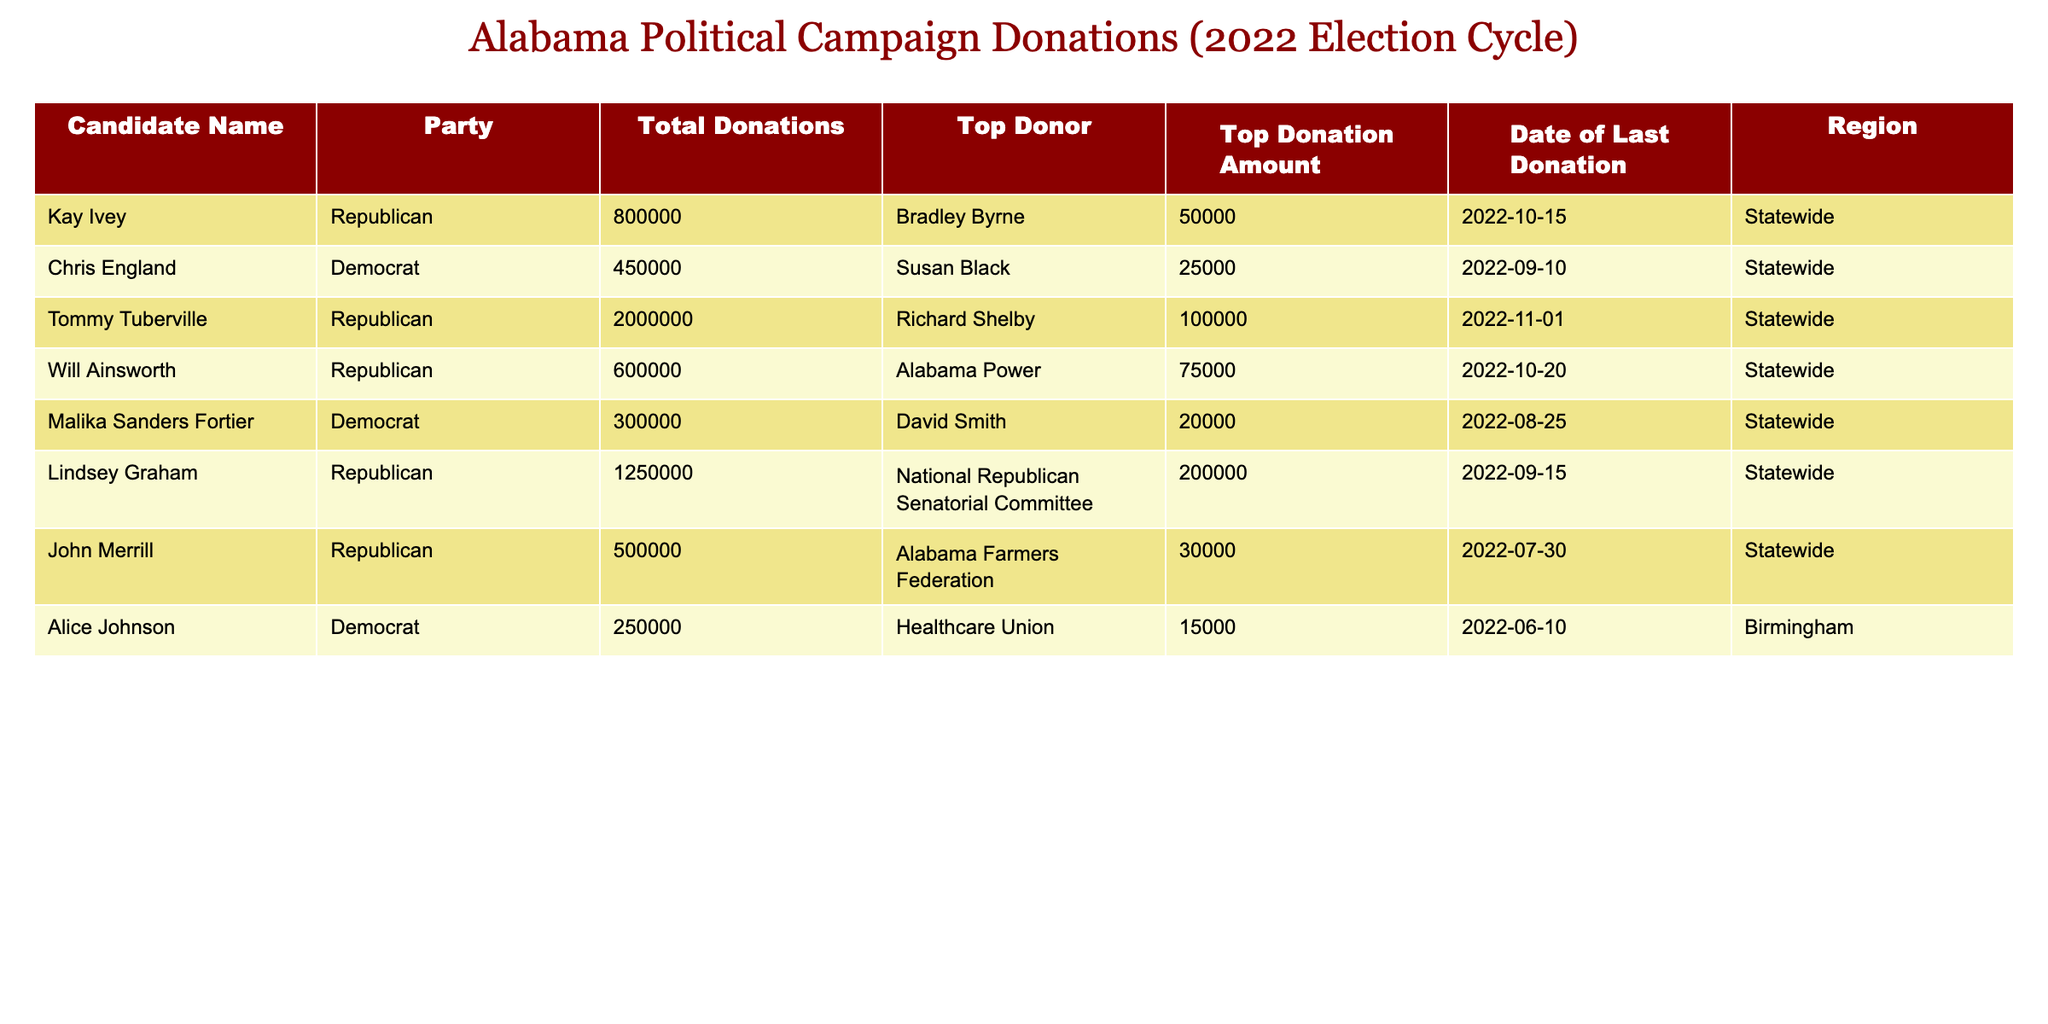What is the total amount of donations received by Tommy Tuberville? The table lists Tommy Tuberville's total donations under the "Total Donations" column, which shows the value of 2,000,000.
Answer: 2,000,000 Who is the top donor for Kay Ivey, and how much did they donate? By looking at the "Top Donor" column for Kay Ivey, we find that the top donor is listed as Bradley Byrne, with a donation amount of 50,000 found in the "Top Donation Amount" column.
Answer: Bradley Byrne, 50,000 What is the average total donation amount for all the candidates listed? To calculate the average, first sum all the total donations: 800,000 + 450,000 + 2,000,000 + 600,000 + 300,000 + 1,250,000 + 500,000 + 250,000 = 6,150,000. The number of candidates is 8. Thus, the average is 6,150,000 / 8 = 768,750.
Answer: 768,750 Did Malika Sanders Fortier receive more donations than Alice Johnson? The total donations for Malika Sanders Fortier is 300,000, while for Alice Johnson, it is 250,000. Since 300,000 is greater than 250,000, the answer is yes.
Answer: Yes Which party has the highest total donations from all candidates combined? For Republicans: 800,000 + 2,000,000 + 600,000 + 1,250,000 + 500,000 = 5,250,000. For Democrats: 450,000 + 300,000 + 250,000 = 1,000,000. The total donations show that Republicans have a higher sum at 5,250,000 compared to 1,000,000 for Democrats.
Answer: Republican What is the date of the last donation received by Lindsey Graham? The table indicates that the "Date of Last Donation" for Lindsey Graham is 2022-09-15.
Answer: 2022-09-15 Are there more candidates from the Republican party than from the Democrat party in this table? There are 5 Republicans (Kay Ivey, Tommy Tuberville, Will Ainsworth, Lindsey Graham, John Merrill) and 3 Democrats (Chris England, Malika Sanders Fortier, Alice Johnson). Since 5 is greater than 3, the answer is yes.
Answer: Yes What is the highest donation amount from any single donor across all candidates? By examining the "Top Donation Amount" column, the values are 50,000, 25,000, 100,000, 75,000, 20,000, 200,000, 30,000, and 15,000. The highest value is 200,000, which corresponds to Lindsey Graham's top donor.
Answer: 200,000 